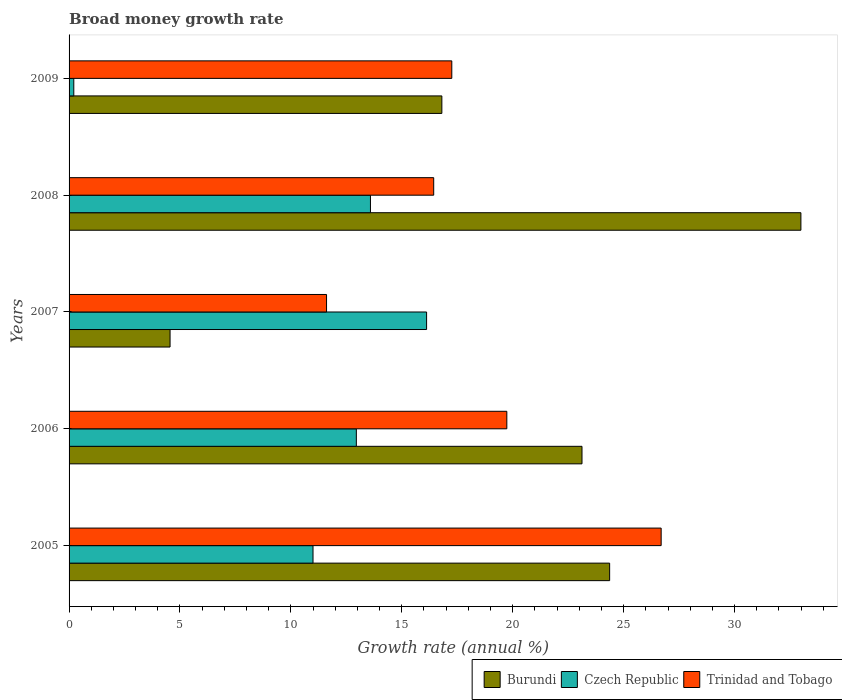How many groups of bars are there?
Your response must be concise. 5. How many bars are there on the 3rd tick from the top?
Your response must be concise. 3. How many bars are there on the 4th tick from the bottom?
Provide a short and direct response. 3. What is the label of the 2nd group of bars from the top?
Provide a succinct answer. 2008. In how many cases, is the number of bars for a given year not equal to the number of legend labels?
Provide a succinct answer. 0. What is the growth rate in Burundi in 2009?
Provide a succinct answer. 16.81. Across all years, what is the maximum growth rate in Czech Republic?
Your answer should be compact. 16.12. Across all years, what is the minimum growth rate in Burundi?
Offer a terse response. 4.55. In which year was the growth rate in Czech Republic maximum?
Offer a terse response. 2007. In which year was the growth rate in Burundi minimum?
Provide a short and direct response. 2007. What is the total growth rate in Czech Republic in the graph?
Offer a terse response. 53.86. What is the difference between the growth rate in Burundi in 2005 and that in 2006?
Give a very brief answer. 1.25. What is the difference between the growth rate in Trinidad and Tobago in 2006 and the growth rate in Burundi in 2005?
Your answer should be compact. -4.63. What is the average growth rate in Czech Republic per year?
Provide a short and direct response. 10.77. In the year 2005, what is the difference between the growth rate in Trinidad and Tobago and growth rate in Czech Republic?
Provide a short and direct response. 15.69. In how many years, is the growth rate in Trinidad and Tobago greater than 31 %?
Provide a short and direct response. 0. What is the ratio of the growth rate in Trinidad and Tobago in 2007 to that in 2009?
Your answer should be very brief. 0.67. Is the growth rate in Trinidad and Tobago in 2007 less than that in 2009?
Your response must be concise. Yes. What is the difference between the highest and the second highest growth rate in Trinidad and Tobago?
Offer a very short reply. 6.96. What is the difference between the highest and the lowest growth rate in Czech Republic?
Your answer should be very brief. 15.9. Is the sum of the growth rate in Burundi in 2008 and 2009 greater than the maximum growth rate in Czech Republic across all years?
Keep it short and to the point. Yes. What does the 3rd bar from the top in 2006 represents?
Ensure brevity in your answer.  Burundi. What does the 1st bar from the bottom in 2007 represents?
Give a very brief answer. Burundi. How many bars are there?
Make the answer very short. 15. How many years are there in the graph?
Your answer should be compact. 5. How many legend labels are there?
Keep it short and to the point. 3. How are the legend labels stacked?
Give a very brief answer. Horizontal. What is the title of the graph?
Provide a short and direct response. Broad money growth rate. Does "Cambodia" appear as one of the legend labels in the graph?
Offer a very short reply. No. What is the label or title of the X-axis?
Your answer should be compact. Growth rate (annual %). What is the Growth rate (annual %) of Burundi in 2005?
Offer a very short reply. 24.37. What is the Growth rate (annual %) in Czech Republic in 2005?
Keep it short and to the point. 11. What is the Growth rate (annual %) of Trinidad and Tobago in 2005?
Provide a short and direct response. 26.69. What is the Growth rate (annual %) of Burundi in 2006?
Your answer should be very brief. 23.12. What is the Growth rate (annual %) in Czech Republic in 2006?
Offer a very short reply. 12.95. What is the Growth rate (annual %) of Trinidad and Tobago in 2006?
Your response must be concise. 19.73. What is the Growth rate (annual %) in Burundi in 2007?
Ensure brevity in your answer.  4.55. What is the Growth rate (annual %) of Czech Republic in 2007?
Ensure brevity in your answer.  16.12. What is the Growth rate (annual %) in Trinidad and Tobago in 2007?
Offer a very short reply. 11.61. What is the Growth rate (annual %) in Burundi in 2008?
Ensure brevity in your answer.  32.99. What is the Growth rate (annual %) in Czech Republic in 2008?
Provide a succinct answer. 13.59. What is the Growth rate (annual %) in Trinidad and Tobago in 2008?
Your response must be concise. 16.44. What is the Growth rate (annual %) of Burundi in 2009?
Keep it short and to the point. 16.81. What is the Growth rate (annual %) of Czech Republic in 2009?
Make the answer very short. 0.21. What is the Growth rate (annual %) of Trinidad and Tobago in 2009?
Keep it short and to the point. 17.25. Across all years, what is the maximum Growth rate (annual %) of Burundi?
Your response must be concise. 32.99. Across all years, what is the maximum Growth rate (annual %) of Czech Republic?
Offer a terse response. 16.12. Across all years, what is the maximum Growth rate (annual %) in Trinidad and Tobago?
Give a very brief answer. 26.69. Across all years, what is the minimum Growth rate (annual %) in Burundi?
Offer a terse response. 4.55. Across all years, what is the minimum Growth rate (annual %) of Czech Republic?
Offer a very short reply. 0.21. Across all years, what is the minimum Growth rate (annual %) of Trinidad and Tobago?
Keep it short and to the point. 11.61. What is the total Growth rate (annual %) in Burundi in the graph?
Your answer should be compact. 101.84. What is the total Growth rate (annual %) in Czech Republic in the graph?
Your answer should be very brief. 53.86. What is the total Growth rate (annual %) in Trinidad and Tobago in the graph?
Make the answer very short. 91.72. What is the difference between the Growth rate (annual %) in Burundi in 2005 and that in 2006?
Keep it short and to the point. 1.25. What is the difference between the Growth rate (annual %) of Czech Republic in 2005 and that in 2006?
Provide a succinct answer. -1.95. What is the difference between the Growth rate (annual %) of Trinidad and Tobago in 2005 and that in 2006?
Your answer should be very brief. 6.96. What is the difference between the Growth rate (annual %) in Burundi in 2005 and that in 2007?
Offer a very short reply. 19.82. What is the difference between the Growth rate (annual %) in Czech Republic in 2005 and that in 2007?
Provide a short and direct response. -5.12. What is the difference between the Growth rate (annual %) in Trinidad and Tobago in 2005 and that in 2007?
Ensure brevity in your answer.  15.08. What is the difference between the Growth rate (annual %) of Burundi in 2005 and that in 2008?
Your response must be concise. -8.62. What is the difference between the Growth rate (annual %) of Czech Republic in 2005 and that in 2008?
Your answer should be compact. -2.59. What is the difference between the Growth rate (annual %) in Trinidad and Tobago in 2005 and that in 2008?
Your answer should be very brief. 10.25. What is the difference between the Growth rate (annual %) in Burundi in 2005 and that in 2009?
Provide a succinct answer. 7.56. What is the difference between the Growth rate (annual %) of Czech Republic in 2005 and that in 2009?
Your response must be concise. 10.78. What is the difference between the Growth rate (annual %) of Trinidad and Tobago in 2005 and that in 2009?
Provide a short and direct response. 9.44. What is the difference between the Growth rate (annual %) of Burundi in 2006 and that in 2007?
Provide a short and direct response. 18.57. What is the difference between the Growth rate (annual %) in Czech Republic in 2006 and that in 2007?
Provide a short and direct response. -3.17. What is the difference between the Growth rate (annual %) in Trinidad and Tobago in 2006 and that in 2007?
Ensure brevity in your answer.  8.13. What is the difference between the Growth rate (annual %) in Burundi in 2006 and that in 2008?
Offer a very short reply. -9.87. What is the difference between the Growth rate (annual %) in Czech Republic in 2006 and that in 2008?
Provide a short and direct response. -0.64. What is the difference between the Growth rate (annual %) of Trinidad and Tobago in 2006 and that in 2008?
Offer a very short reply. 3.3. What is the difference between the Growth rate (annual %) of Burundi in 2006 and that in 2009?
Offer a terse response. 6.32. What is the difference between the Growth rate (annual %) in Czech Republic in 2006 and that in 2009?
Your response must be concise. 12.74. What is the difference between the Growth rate (annual %) in Trinidad and Tobago in 2006 and that in 2009?
Make the answer very short. 2.48. What is the difference between the Growth rate (annual %) of Burundi in 2007 and that in 2008?
Your answer should be compact. -28.44. What is the difference between the Growth rate (annual %) of Czech Republic in 2007 and that in 2008?
Keep it short and to the point. 2.53. What is the difference between the Growth rate (annual %) of Trinidad and Tobago in 2007 and that in 2008?
Your answer should be very brief. -4.83. What is the difference between the Growth rate (annual %) of Burundi in 2007 and that in 2009?
Give a very brief answer. -12.25. What is the difference between the Growth rate (annual %) in Czech Republic in 2007 and that in 2009?
Give a very brief answer. 15.9. What is the difference between the Growth rate (annual %) in Trinidad and Tobago in 2007 and that in 2009?
Make the answer very short. -5.65. What is the difference between the Growth rate (annual %) of Burundi in 2008 and that in 2009?
Give a very brief answer. 16.19. What is the difference between the Growth rate (annual %) in Czech Republic in 2008 and that in 2009?
Make the answer very short. 13.37. What is the difference between the Growth rate (annual %) of Trinidad and Tobago in 2008 and that in 2009?
Ensure brevity in your answer.  -0.82. What is the difference between the Growth rate (annual %) in Burundi in 2005 and the Growth rate (annual %) in Czech Republic in 2006?
Ensure brevity in your answer.  11.42. What is the difference between the Growth rate (annual %) in Burundi in 2005 and the Growth rate (annual %) in Trinidad and Tobago in 2006?
Provide a short and direct response. 4.63. What is the difference between the Growth rate (annual %) in Czech Republic in 2005 and the Growth rate (annual %) in Trinidad and Tobago in 2006?
Give a very brief answer. -8.74. What is the difference between the Growth rate (annual %) in Burundi in 2005 and the Growth rate (annual %) in Czech Republic in 2007?
Ensure brevity in your answer.  8.25. What is the difference between the Growth rate (annual %) of Burundi in 2005 and the Growth rate (annual %) of Trinidad and Tobago in 2007?
Provide a short and direct response. 12.76. What is the difference between the Growth rate (annual %) of Czech Republic in 2005 and the Growth rate (annual %) of Trinidad and Tobago in 2007?
Give a very brief answer. -0.61. What is the difference between the Growth rate (annual %) in Burundi in 2005 and the Growth rate (annual %) in Czech Republic in 2008?
Your answer should be very brief. 10.78. What is the difference between the Growth rate (annual %) of Burundi in 2005 and the Growth rate (annual %) of Trinidad and Tobago in 2008?
Give a very brief answer. 7.93. What is the difference between the Growth rate (annual %) in Czech Republic in 2005 and the Growth rate (annual %) in Trinidad and Tobago in 2008?
Ensure brevity in your answer.  -5.44. What is the difference between the Growth rate (annual %) of Burundi in 2005 and the Growth rate (annual %) of Czech Republic in 2009?
Provide a succinct answer. 24.16. What is the difference between the Growth rate (annual %) in Burundi in 2005 and the Growth rate (annual %) in Trinidad and Tobago in 2009?
Keep it short and to the point. 7.12. What is the difference between the Growth rate (annual %) in Czech Republic in 2005 and the Growth rate (annual %) in Trinidad and Tobago in 2009?
Ensure brevity in your answer.  -6.26. What is the difference between the Growth rate (annual %) of Burundi in 2006 and the Growth rate (annual %) of Czech Republic in 2007?
Your response must be concise. 7.01. What is the difference between the Growth rate (annual %) of Burundi in 2006 and the Growth rate (annual %) of Trinidad and Tobago in 2007?
Offer a terse response. 11.52. What is the difference between the Growth rate (annual %) in Czech Republic in 2006 and the Growth rate (annual %) in Trinidad and Tobago in 2007?
Your response must be concise. 1.34. What is the difference between the Growth rate (annual %) of Burundi in 2006 and the Growth rate (annual %) of Czech Republic in 2008?
Make the answer very short. 9.54. What is the difference between the Growth rate (annual %) in Burundi in 2006 and the Growth rate (annual %) in Trinidad and Tobago in 2008?
Make the answer very short. 6.69. What is the difference between the Growth rate (annual %) of Czech Republic in 2006 and the Growth rate (annual %) of Trinidad and Tobago in 2008?
Your response must be concise. -3.49. What is the difference between the Growth rate (annual %) of Burundi in 2006 and the Growth rate (annual %) of Czech Republic in 2009?
Provide a succinct answer. 22.91. What is the difference between the Growth rate (annual %) in Burundi in 2006 and the Growth rate (annual %) in Trinidad and Tobago in 2009?
Your answer should be compact. 5.87. What is the difference between the Growth rate (annual %) in Czech Republic in 2006 and the Growth rate (annual %) in Trinidad and Tobago in 2009?
Ensure brevity in your answer.  -4.3. What is the difference between the Growth rate (annual %) in Burundi in 2007 and the Growth rate (annual %) in Czech Republic in 2008?
Ensure brevity in your answer.  -9.03. What is the difference between the Growth rate (annual %) of Burundi in 2007 and the Growth rate (annual %) of Trinidad and Tobago in 2008?
Offer a very short reply. -11.88. What is the difference between the Growth rate (annual %) in Czech Republic in 2007 and the Growth rate (annual %) in Trinidad and Tobago in 2008?
Provide a succinct answer. -0.32. What is the difference between the Growth rate (annual %) in Burundi in 2007 and the Growth rate (annual %) in Czech Republic in 2009?
Provide a short and direct response. 4.34. What is the difference between the Growth rate (annual %) of Burundi in 2007 and the Growth rate (annual %) of Trinidad and Tobago in 2009?
Offer a terse response. -12.7. What is the difference between the Growth rate (annual %) of Czech Republic in 2007 and the Growth rate (annual %) of Trinidad and Tobago in 2009?
Keep it short and to the point. -1.14. What is the difference between the Growth rate (annual %) in Burundi in 2008 and the Growth rate (annual %) in Czech Republic in 2009?
Your answer should be very brief. 32.78. What is the difference between the Growth rate (annual %) in Burundi in 2008 and the Growth rate (annual %) in Trinidad and Tobago in 2009?
Give a very brief answer. 15.74. What is the difference between the Growth rate (annual %) of Czech Republic in 2008 and the Growth rate (annual %) of Trinidad and Tobago in 2009?
Ensure brevity in your answer.  -3.67. What is the average Growth rate (annual %) of Burundi per year?
Provide a short and direct response. 20.37. What is the average Growth rate (annual %) in Czech Republic per year?
Give a very brief answer. 10.77. What is the average Growth rate (annual %) in Trinidad and Tobago per year?
Give a very brief answer. 18.34. In the year 2005, what is the difference between the Growth rate (annual %) in Burundi and Growth rate (annual %) in Czech Republic?
Provide a short and direct response. 13.37. In the year 2005, what is the difference between the Growth rate (annual %) of Burundi and Growth rate (annual %) of Trinidad and Tobago?
Make the answer very short. -2.32. In the year 2005, what is the difference between the Growth rate (annual %) of Czech Republic and Growth rate (annual %) of Trinidad and Tobago?
Provide a succinct answer. -15.69. In the year 2006, what is the difference between the Growth rate (annual %) in Burundi and Growth rate (annual %) in Czech Republic?
Offer a very short reply. 10.17. In the year 2006, what is the difference between the Growth rate (annual %) of Burundi and Growth rate (annual %) of Trinidad and Tobago?
Your response must be concise. 3.39. In the year 2006, what is the difference between the Growth rate (annual %) in Czech Republic and Growth rate (annual %) in Trinidad and Tobago?
Give a very brief answer. -6.78. In the year 2007, what is the difference between the Growth rate (annual %) of Burundi and Growth rate (annual %) of Czech Republic?
Ensure brevity in your answer.  -11.56. In the year 2007, what is the difference between the Growth rate (annual %) in Burundi and Growth rate (annual %) in Trinidad and Tobago?
Your response must be concise. -7.05. In the year 2007, what is the difference between the Growth rate (annual %) in Czech Republic and Growth rate (annual %) in Trinidad and Tobago?
Offer a very short reply. 4.51. In the year 2008, what is the difference between the Growth rate (annual %) of Burundi and Growth rate (annual %) of Czech Republic?
Provide a succinct answer. 19.41. In the year 2008, what is the difference between the Growth rate (annual %) of Burundi and Growth rate (annual %) of Trinidad and Tobago?
Your response must be concise. 16.55. In the year 2008, what is the difference between the Growth rate (annual %) in Czech Republic and Growth rate (annual %) in Trinidad and Tobago?
Your answer should be compact. -2.85. In the year 2009, what is the difference between the Growth rate (annual %) of Burundi and Growth rate (annual %) of Czech Republic?
Make the answer very short. 16.59. In the year 2009, what is the difference between the Growth rate (annual %) in Burundi and Growth rate (annual %) in Trinidad and Tobago?
Make the answer very short. -0.45. In the year 2009, what is the difference between the Growth rate (annual %) of Czech Republic and Growth rate (annual %) of Trinidad and Tobago?
Your response must be concise. -17.04. What is the ratio of the Growth rate (annual %) of Burundi in 2005 to that in 2006?
Your response must be concise. 1.05. What is the ratio of the Growth rate (annual %) in Czech Republic in 2005 to that in 2006?
Offer a very short reply. 0.85. What is the ratio of the Growth rate (annual %) in Trinidad and Tobago in 2005 to that in 2006?
Provide a succinct answer. 1.35. What is the ratio of the Growth rate (annual %) of Burundi in 2005 to that in 2007?
Give a very brief answer. 5.35. What is the ratio of the Growth rate (annual %) of Czech Republic in 2005 to that in 2007?
Keep it short and to the point. 0.68. What is the ratio of the Growth rate (annual %) of Trinidad and Tobago in 2005 to that in 2007?
Make the answer very short. 2.3. What is the ratio of the Growth rate (annual %) of Burundi in 2005 to that in 2008?
Ensure brevity in your answer.  0.74. What is the ratio of the Growth rate (annual %) in Czech Republic in 2005 to that in 2008?
Your response must be concise. 0.81. What is the ratio of the Growth rate (annual %) in Trinidad and Tobago in 2005 to that in 2008?
Provide a succinct answer. 1.62. What is the ratio of the Growth rate (annual %) of Burundi in 2005 to that in 2009?
Provide a short and direct response. 1.45. What is the ratio of the Growth rate (annual %) of Czech Republic in 2005 to that in 2009?
Give a very brief answer. 51.55. What is the ratio of the Growth rate (annual %) of Trinidad and Tobago in 2005 to that in 2009?
Ensure brevity in your answer.  1.55. What is the ratio of the Growth rate (annual %) in Burundi in 2006 to that in 2007?
Your response must be concise. 5.08. What is the ratio of the Growth rate (annual %) in Czech Republic in 2006 to that in 2007?
Your response must be concise. 0.8. What is the ratio of the Growth rate (annual %) in Trinidad and Tobago in 2006 to that in 2007?
Provide a short and direct response. 1.7. What is the ratio of the Growth rate (annual %) in Burundi in 2006 to that in 2008?
Your answer should be compact. 0.7. What is the ratio of the Growth rate (annual %) in Czech Republic in 2006 to that in 2008?
Provide a succinct answer. 0.95. What is the ratio of the Growth rate (annual %) of Trinidad and Tobago in 2006 to that in 2008?
Provide a succinct answer. 1.2. What is the ratio of the Growth rate (annual %) of Burundi in 2006 to that in 2009?
Your answer should be compact. 1.38. What is the ratio of the Growth rate (annual %) in Czech Republic in 2006 to that in 2009?
Your answer should be very brief. 60.71. What is the ratio of the Growth rate (annual %) in Trinidad and Tobago in 2006 to that in 2009?
Your answer should be compact. 1.14. What is the ratio of the Growth rate (annual %) in Burundi in 2007 to that in 2008?
Keep it short and to the point. 0.14. What is the ratio of the Growth rate (annual %) in Czech Republic in 2007 to that in 2008?
Your answer should be very brief. 1.19. What is the ratio of the Growth rate (annual %) in Trinidad and Tobago in 2007 to that in 2008?
Offer a terse response. 0.71. What is the ratio of the Growth rate (annual %) in Burundi in 2007 to that in 2009?
Your response must be concise. 0.27. What is the ratio of the Growth rate (annual %) of Czech Republic in 2007 to that in 2009?
Your answer should be very brief. 75.55. What is the ratio of the Growth rate (annual %) of Trinidad and Tobago in 2007 to that in 2009?
Make the answer very short. 0.67. What is the ratio of the Growth rate (annual %) in Burundi in 2008 to that in 2009?
Your answer should be very brief. 1.96. What is the ratio of the Growth rate (annual %) in Czech Republic in 2008 to that in 2009?
Your answer should be compact. 63.69. What is the ratio of the Growth rate (annual %) in Trinidad and Tobago in 2008 to that in 2009?
Your response must be concise. 0.95. What is the difference between the highest and the second highest Growth rate (annual %) in Burundi?
Ensure brevity in your answer.  8.62. What is the difference between the highest and the second highest Growth rate (annual %) in Czech Republic?
Provide a short and direct response. 2.53. What is the difference between the highest and the second highest Growth rate (annual %) in Trinidad and Tobago?
Your answer should be compact. 6.96. What is the difference between the highest and the lowest Growth rate (annual %) in Burundi?
Offer a terse response. 28.44. What is the difference between the highest and the lowest Growth rate (annual %) in Czech Republic?
Provide a succinct answer. 15.9. What is the difference between the highest and the lowest Growth rate (annual %) of Trinidad and Tobago?
Ensure brevity in your answer.  15.08. 